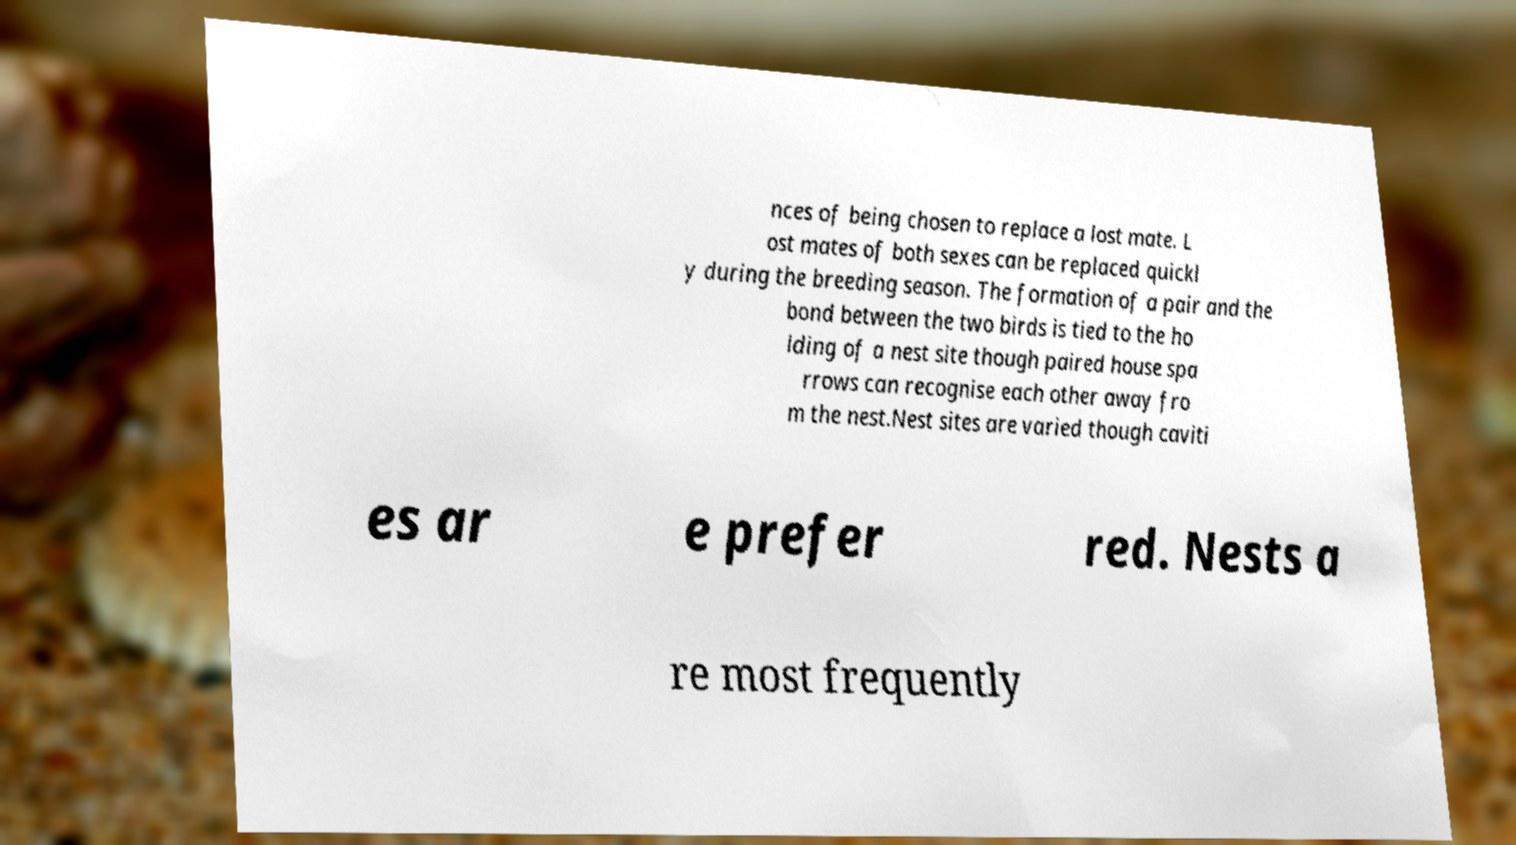There's text embedded in this image that I need extracted. Can you transcribe it verbatim? nces of being chosen to replace a lost mate. L ost mates of both sexes can be replaced quickl y during the breeding season. The formation of a pair and the bond between the two birds is tied to the ho lding of a nest site though paired house spa rrows can recognise each other away fro m the nest.Nest sites are varied though caviti es ar e prefer red. Nests a re most frequently 